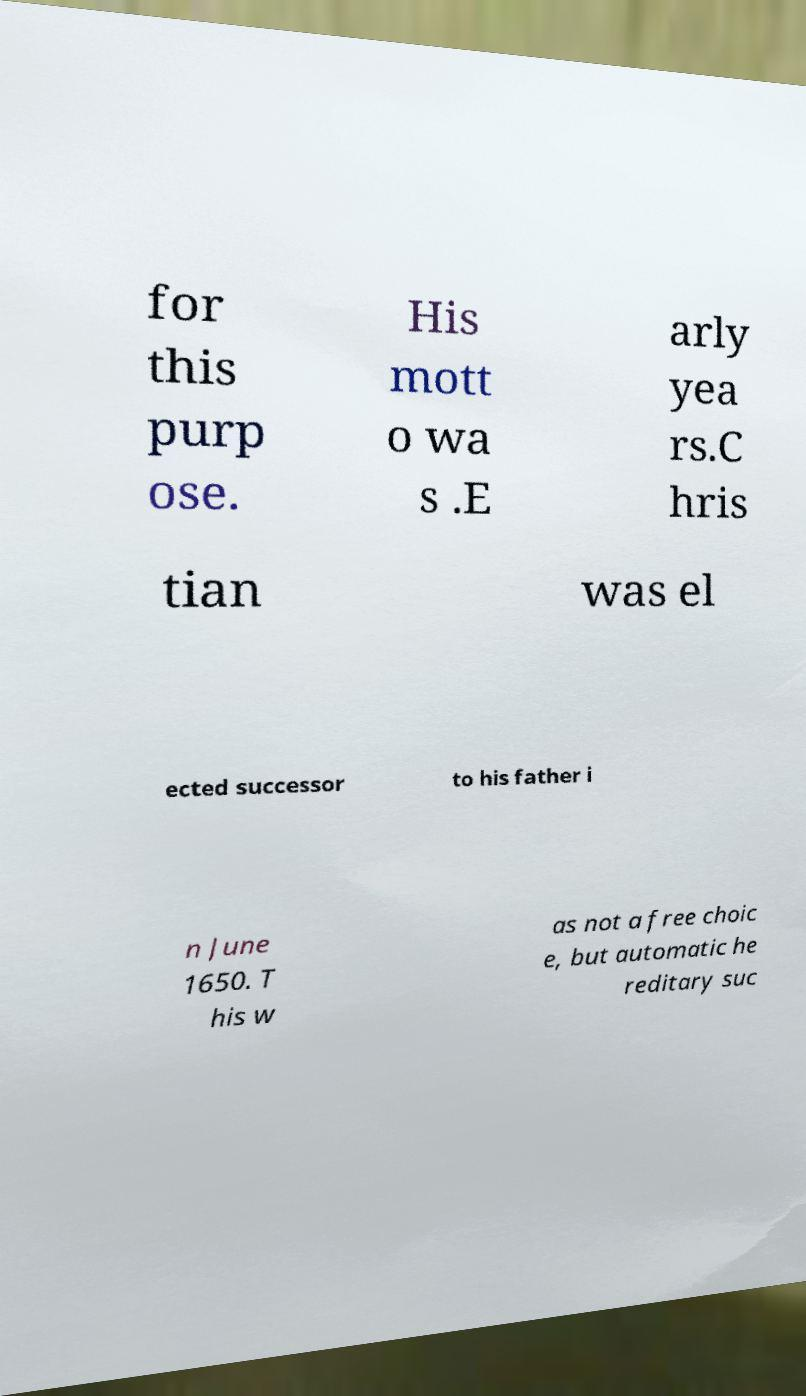Could you extract and type out the text from this image? for this purp ose. His mott o wa s .E arly yea rs.C hris tian was el ected successor to his father i n June 1650. T his w as not a free choic e, but automatic he reditary suc 